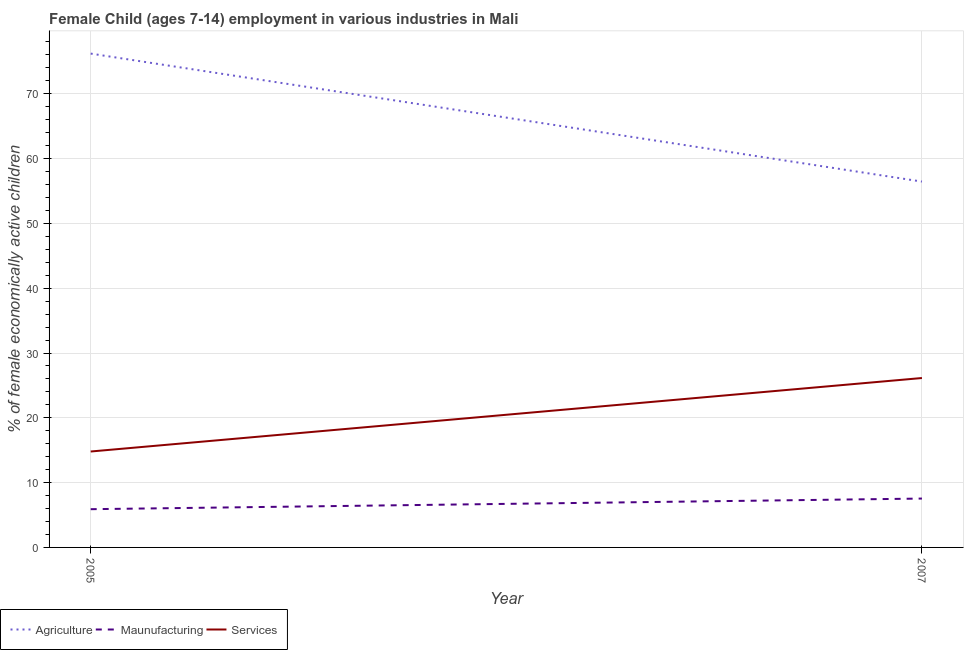How many different coloured lines are there?
Provide a succinct answer. 3. Is the number of lines equal to the number of legend labels?
Give a very brief answer. Yes. What is the percentage of economically active children in agriculture in 2005?
Provide a short and direct response. 76.2. Across all years, what is the maximum percentage of economically active children in manufacturing?
Your answer should be compact. 7.54. What is the total percentage of economically active children in services in the graph?
Your response must be concise. 40.94. What is the difference between the percentage of economically active children in manufacturing in 2005 and that in 2007?
Provide a succinct answer. -1.64. What is the difference between the percentage of economically active children in agriculture in 2007 and the percentage of economically active children in manufacturing in 2005?
Provide a succinct answer. 50.55. What is the average percentage of economically active children in services per year?
Your answer should be very brief. 20.47. In how many years, is the percentage of economically active children in agriculture greater than 58 %?
Provide a succinct answer. 1. What is the ratio of the percentage of economically active children in services in 2005 to that in 2007?
Offer a very short reply. 0.57. In how many years, is the percentage of economically active children in services greater than the average percentage of economically active children in services taken over all years?
Make the answer very short. 1. Is it the case that in every year, the sum of the percentage of economically active children in agriculture and percentage of economically active children in manufacturing is greater than the percentage of economically active children in services?
Offer a very short reply. Yes. Does the percentage of economically active children in manufacturing monotonically increase over the years?
Ensure brevity in your answer.  Yes. Is the percentage of economically active children in agriculture strictly less than the percentage of economically active children in manufacturing over the years?
Offer a very short reply. No. How many lines are there?
Make the answer very short. 3. How many years are there in the graph?
Provide a short and direct response. 2. What is the difference between two consecutive major ticks on the Y-axis?
Ensure brevity in your answer.  10. Are the values on the major ticks of Y-axis written in scientific E-notation?
Your answer should be very brief. No. Does the graph contain any zero values?
Your answer should be compact. No. Does the graph contain grids?
Make the answer very short. Yes. Where does the legend appear in the graph?
Provide a short and direct response. Bottom left. How many legend labels are there?
Give a very brief answer. 3. How are the legend labels stacked?
Your answer should be compact. Horizontal. What is the title of the graph?
Provide a succinct answer. Female Child (ages 7-14) employment in various industries in Mali. What is the label or title of the X-axis?
Ensure brevity in your answer.  Year. What is the label or title of the Y-axis?
Offer a very short reply. % of female economically active children. What is the % of female economically active children of Agriculture in 2005?
Make the answer very short. 76.2. What is the % of female economically active children of Agriculture in 2007?
Your response must be concise. 56.45. What is the % of female economically active children in Maunufacturing in 2007?
Make the answer very short. 7.54. What is the % of female economically active children in Services in 2007?
Your response must be concise. 26.14. Across all years, what is the maximum % of female economically active children in Agriculture?
Make the answer very short. 76.2. Across all years, what is the maximum % of female economically active children in Maunufacturing?
Ensure brevity in your answer.  7.54. Across all years, what is the maximum % of female economically active children of Services?
Give a very brief answer. 26.14. Across all years, what is the minimum % of female economically active children in Agriculture?
Offer a very short reply. 56.45. Across all years, what is the minimum % of female economically active children of Maunufacturing?
Your answer should be compact. 5.9. What is the total % of female economically active children of Agriculture in the graph?
Your answer should be very brief. 132.65. What is the total % of female economically active children in Maunufacturing in the graph?
Make the answer very short. 13.44. What is the total % of female economically active children in Services in the graph?
Keep it short and to the point. 40.94. What is the difference between the % of female economically active children of Agriculture in 2005 and that in 2007?
Make the answer very short. 19.75. What is the difference between the % of female economically active children in Maunufacturing in 2005 and that in 2007?
Give a very brief answer. -1.64. What is the difference between the % of female economically active children in Services in 2005 and that in 2007?
Provide a succinct answer. -11.34. What is the difference between the % of female economically active children in Agriculture in 2005 and the % of female economically active children in Maunufacturing in 2007?
Give a very brief answer. 68.66. What is the difference between the % of female economically active children in Agriculture in 2005 and the % of female economically active children in Services in 2007?
Provide a short and direct response. 50.06. What is the difference between the % of female economically active children in Maunufacturing in 2005 and the % of female economically active children in Services in 2007?
Your answer should be compact. -20.24. What is the average % of female economically active children in Agriculture per year?
Your answer should be compact. 66.33. What is the average % of female economically active children in Maunufacturing per year?
Provide a short and direct response. 6.72. What is the average % of female economically active children of Services per year?
Provide a short and direct response. 20.47. In the year 2005, what is the difference between the % of female economically active children in Agriculture and % of female economically active children in Maunufacturing?
Your answer should be compact. 70.3. In the year 2005, what is the difference between the % of female economically active children of Agriculture and % of female economically active children of Services?
Ensure brevity in your answer.  61.4. In the year 2007, what is the difference between the % of female economically active children of Agriculture and % of female economically active children of Maunufacturing?
Provide a succinct answer. 48.91. In the year 2007, what is the difference between the % of female economically active children in Agriculture and % of female economically active children in Services?
Your response must be concise. 30.31. In the year 2007, what is the difference between the % of female economically active children of Maunufacturing and % of female economically active children of Services?
Make the answer very short. -18.6. What is the ratio of the % of female economically active children of Agriculture in 2005 to that in 2007?
Your response must be concise. 1.35. What is the ratio of the % of female economically active children of Maunufacturing in 2005 to that in 2007?
Offer a very short reply. 0.78. What is the ratio of the % of female economically active children of Services in 2005 to that in 2007?
Your answer should be compact. 0.57. What is the difference between the highest and the second highest % of female economically active children in Agriculture?
Your answer should be very brief. 19.75. What is the difference between the highest and the second highest % of female economically active children in Maunufacturing?
Make the answer very short. 1.64. What is the difference between the highest and the second highest % of female economically active children of Services?
Your answer should be very brief. 11.34. What is the difference between the highest and the lowest % of female economically active children of Agriculture?
Provide a succinct answer. 19.75. What is the difference between the highest and the lowest % of female economically active children of Maunufacturing?
Ensure brevity in your answer.  1.64. What is the difference between the highest and the lowest % of female economically active children in Services?
Ensure brevity in your answer.  11.34. 